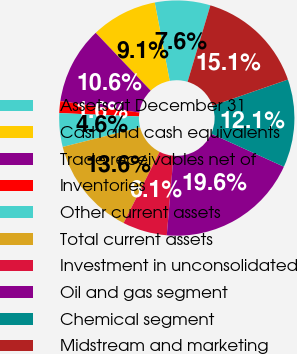Convert chart. <chart><loc_0><loc_0><loc_500><loc_500><pie_chart><fcel>Assets at December 31<fcel>Cash and cash equivalents<fcel>Trade receivables net of<fcel>Inventories<fcel>Other current assets<fcel>Total current assets<fcel>Investment in unconsolidated<fcel>Oil and gas segment<fcel>Chemical segment<fcel>Midstream and marketing<nl><fcel>7.61%<fcel>9.1%<fcel>10.6%<fcel>1.63%<fcel>4.62%<fcel>13.59%<fcel>6.11%<fcel>19.57%<fcel>12.09%<fcel>15.08%<nl></chart> 